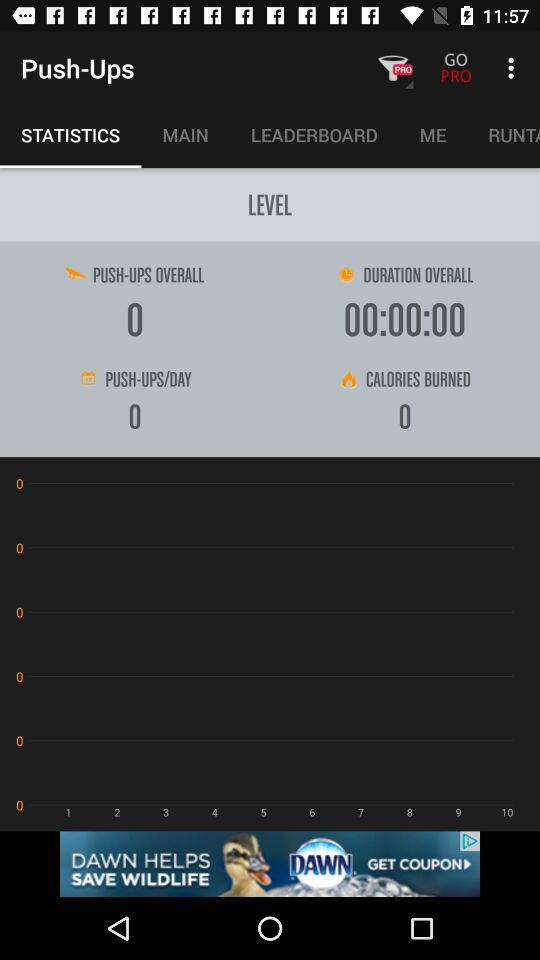What is the number of overall push-ups? The number of overall push-ups is 0. 